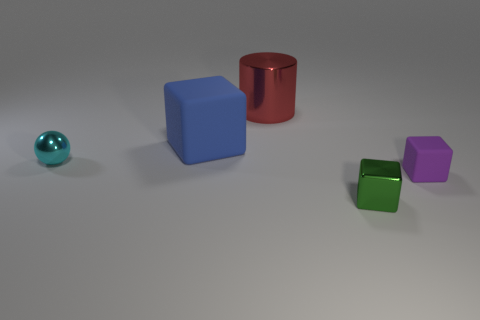Subtract all big rubber cubes. How many cubes are left? 2 Add 4 large blue rubber things. How many objects exist? 9 Subtract 1 cubes. How many cubes are left? 2 Subtract all green blocks. How many blocks are left? 2 Subtract all balls. How many objects are left? 4 Subtract all big cylinders. Subtract all tiny cyan metallic objects. How many objects are left? 3 Add 3 tiny cyan shiny objects. How many tiny cyan shiny objects are left? 4 Add 5 small yellow matte balls. How many small yellow matte balls exist? 5 Subtract 0 blue cylinders. How many objects are left? 5 Subtract all yellow cylinders. Subtract all yellow balls. How many cylinders are left? 1 